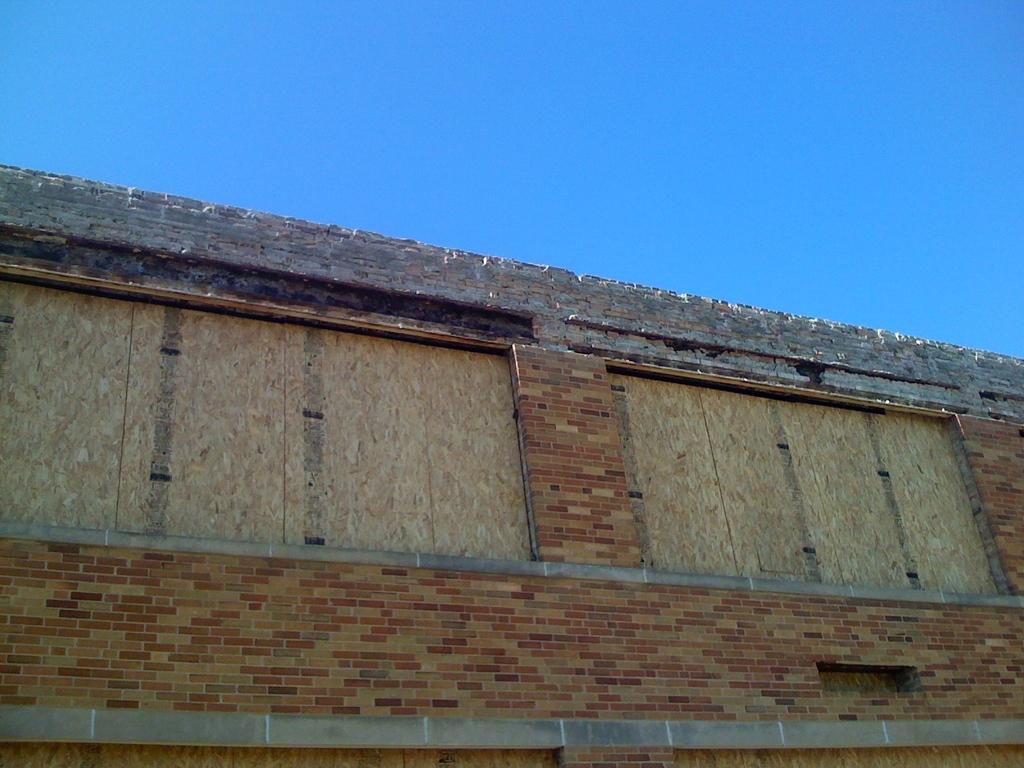What is the main structure in the center of the image? There is a wall in the center of the image. What can be seen above the wall in the image? The sky is visible at the top of the image. How many credits are needed to purchase the tent in the image? There is no tent present in the image, so the number of credits needed cannot be determined. 